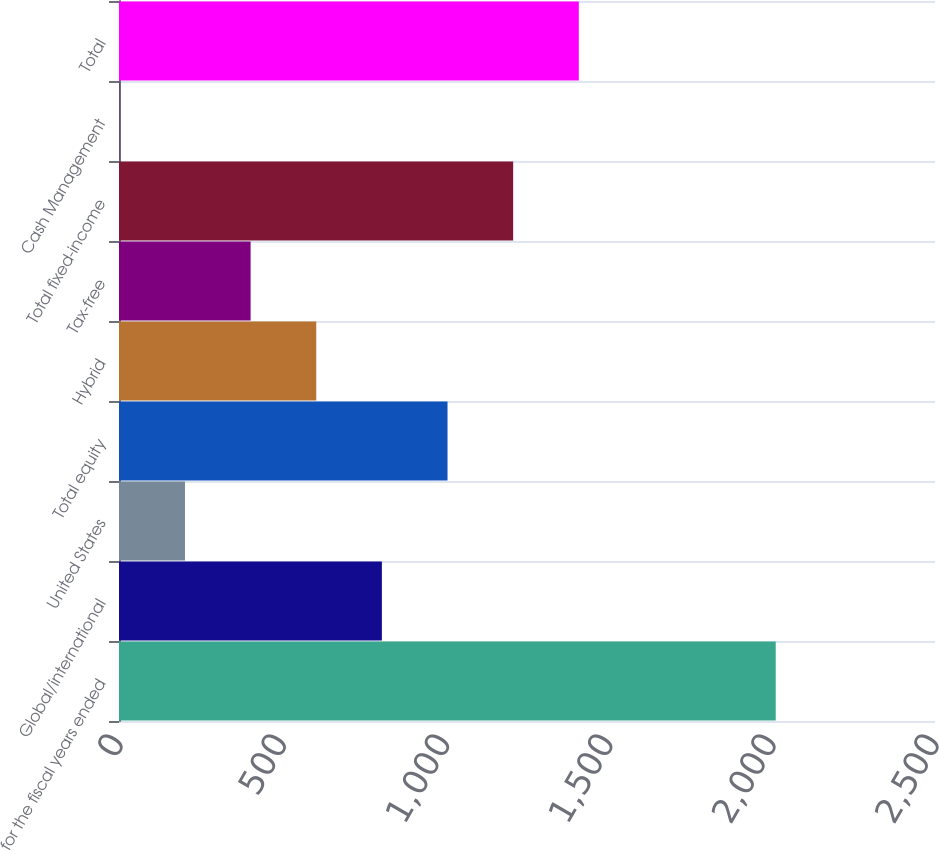<chart> <loc_0><loc_0><loc_500><loc_500><bar_chart><fcel>for the fiscal years ended<fcel>Global/international<fcel>United States<fcel>Total equity<fcel>Hybrid<fcel>Tax-free<fcel>Total fixed-income<fcel>Cash Management<fcel>Total<nl><fcel>2012<fcel>805.4<fcel>202.1<fcel>1006.5<fcel>604.3<fcel>403.2<fcel>1207.6<fcel>1<fcel>1408.7<nl></chart> 